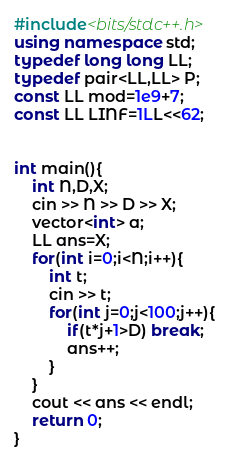Convert code to text. <code><loc_0><loc_0><loc_500><loc_500><_C++_>#include<bits/stdc++.h>
using namespace std;
typedef long long LL;
typedef pair<LL,LL> P;
const LL mod=1e9+7;
const LL LINF=1LL<<62;


int main(){
    int N,D,X;
    cin >> N >> D >> X;
    vector<int> a;
    LL ans=X;
    for(int i=0;i<N;i++){
        int t;
        cin >> t;
        for(int j=0;j<100;j++){
            if(t*j+1>D) break;
            ans++;
        }
    }
    cout << ans << endl;
    return 0;
}</code> 